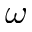Convert formula to latex. <formula><loc_0><loc_0><loc_500><loc_500>\omega</formula> 